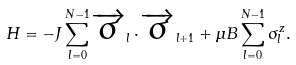Convert formula to latex. <formula><loc_0><loc_0><loc_500><loc_500>H = - J \sum _ { l = 0 } ^ { N - 1 } \overrightarrow { \sigma } _ { l } \cdot \overrightarrow { \sigma } _ { l + 1 } + \mu B \sum _ { l = 0 } ^ { N - 1 } \sigma ^ { z } _ { l } .</formula> 